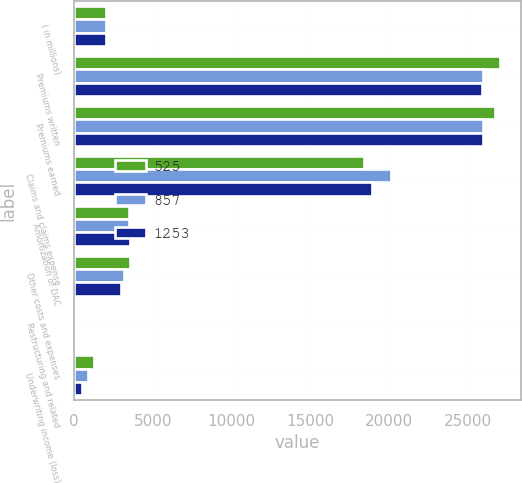Convert chart. <chart><loc_0><loc_0><loc_500><loc_500><stacked_bar_chart><ecel><fcel>( in millions)<fcel>Premiums written<fcel>Premiums earned<fcel>Claims and claims expense<fcel>Amortization of DAC<fcel>Other costs and expenses<fcel>Restructuring and related<fcel>Underwriting income (loss)<nl><fcel>525<fcel>2012<fcel>27026<fcel>26737<fcel>18433<fcel>3483<fcel>3534<fcel>34<fcel>1253<nl><fcel>857<fcel>2011<fcel>25981<fcel>25942<fcel>20140<fcel>3477<fcel>3139<fcel>43<fcel>857<nl><fcel>1253<fcel>2010<fcel>25906<fcel>25955<fcel>18923<fcel>3517<fcel>2957<fcel>33<fcel>525<nl></chart> 